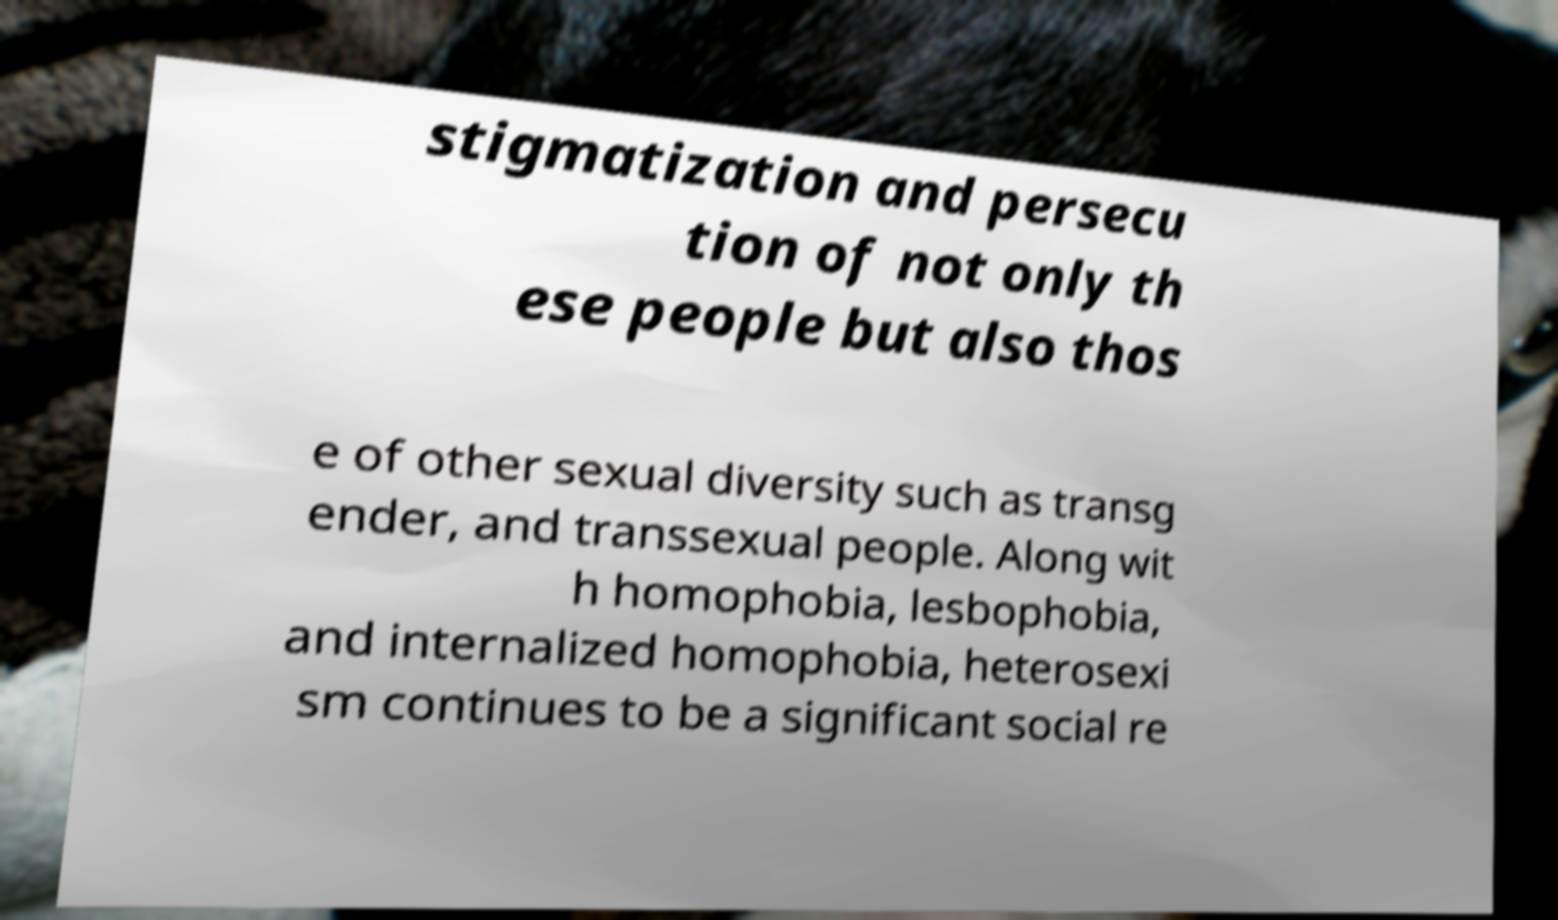Can you read and provide the text displayed in the image?This photo seems to have some interesting text. Can you extract and type it out for me? stigmatization and persecu tion of not only th ese people but also thos e of other sexual diversity such as transg ender, and transsexual people. Along wit h homophobia, lesbophobia, and internalized homophobia, heterosexi sm continues to be a significant social re 